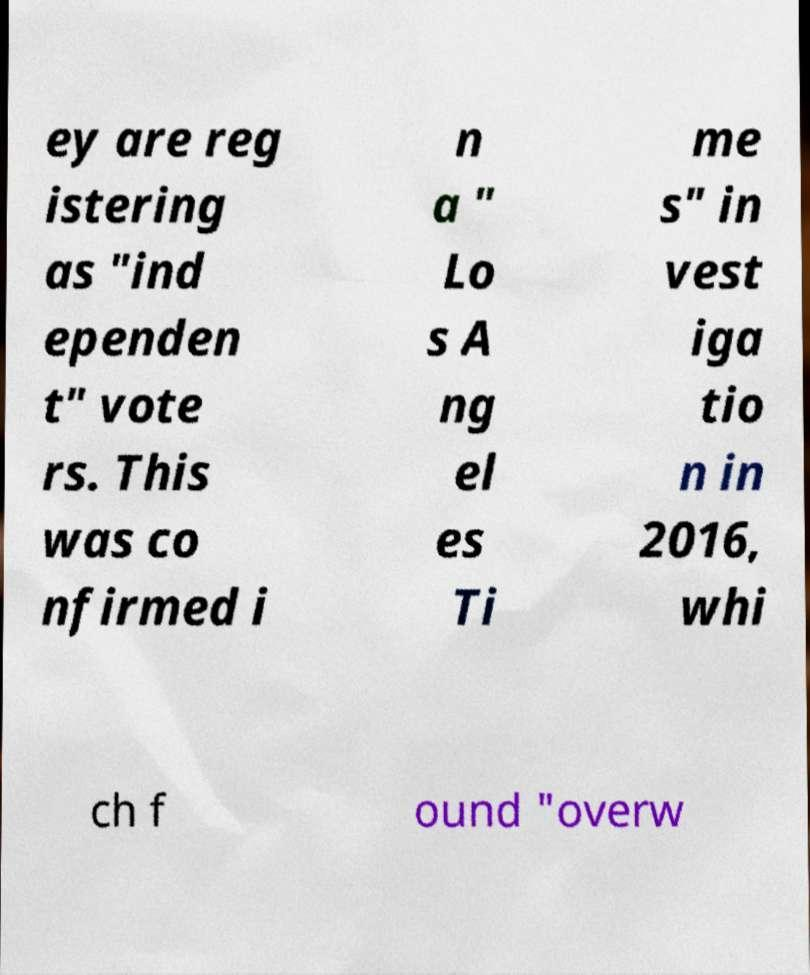Please read and relay the text visible in this image. What does it say? ey are reg istering as "ind ependen t" vote rs. This was co nfirmed i n a " Lo s A ng el es Ti me s" in vest iga tio n in 2016, whi ch f ound "overw 